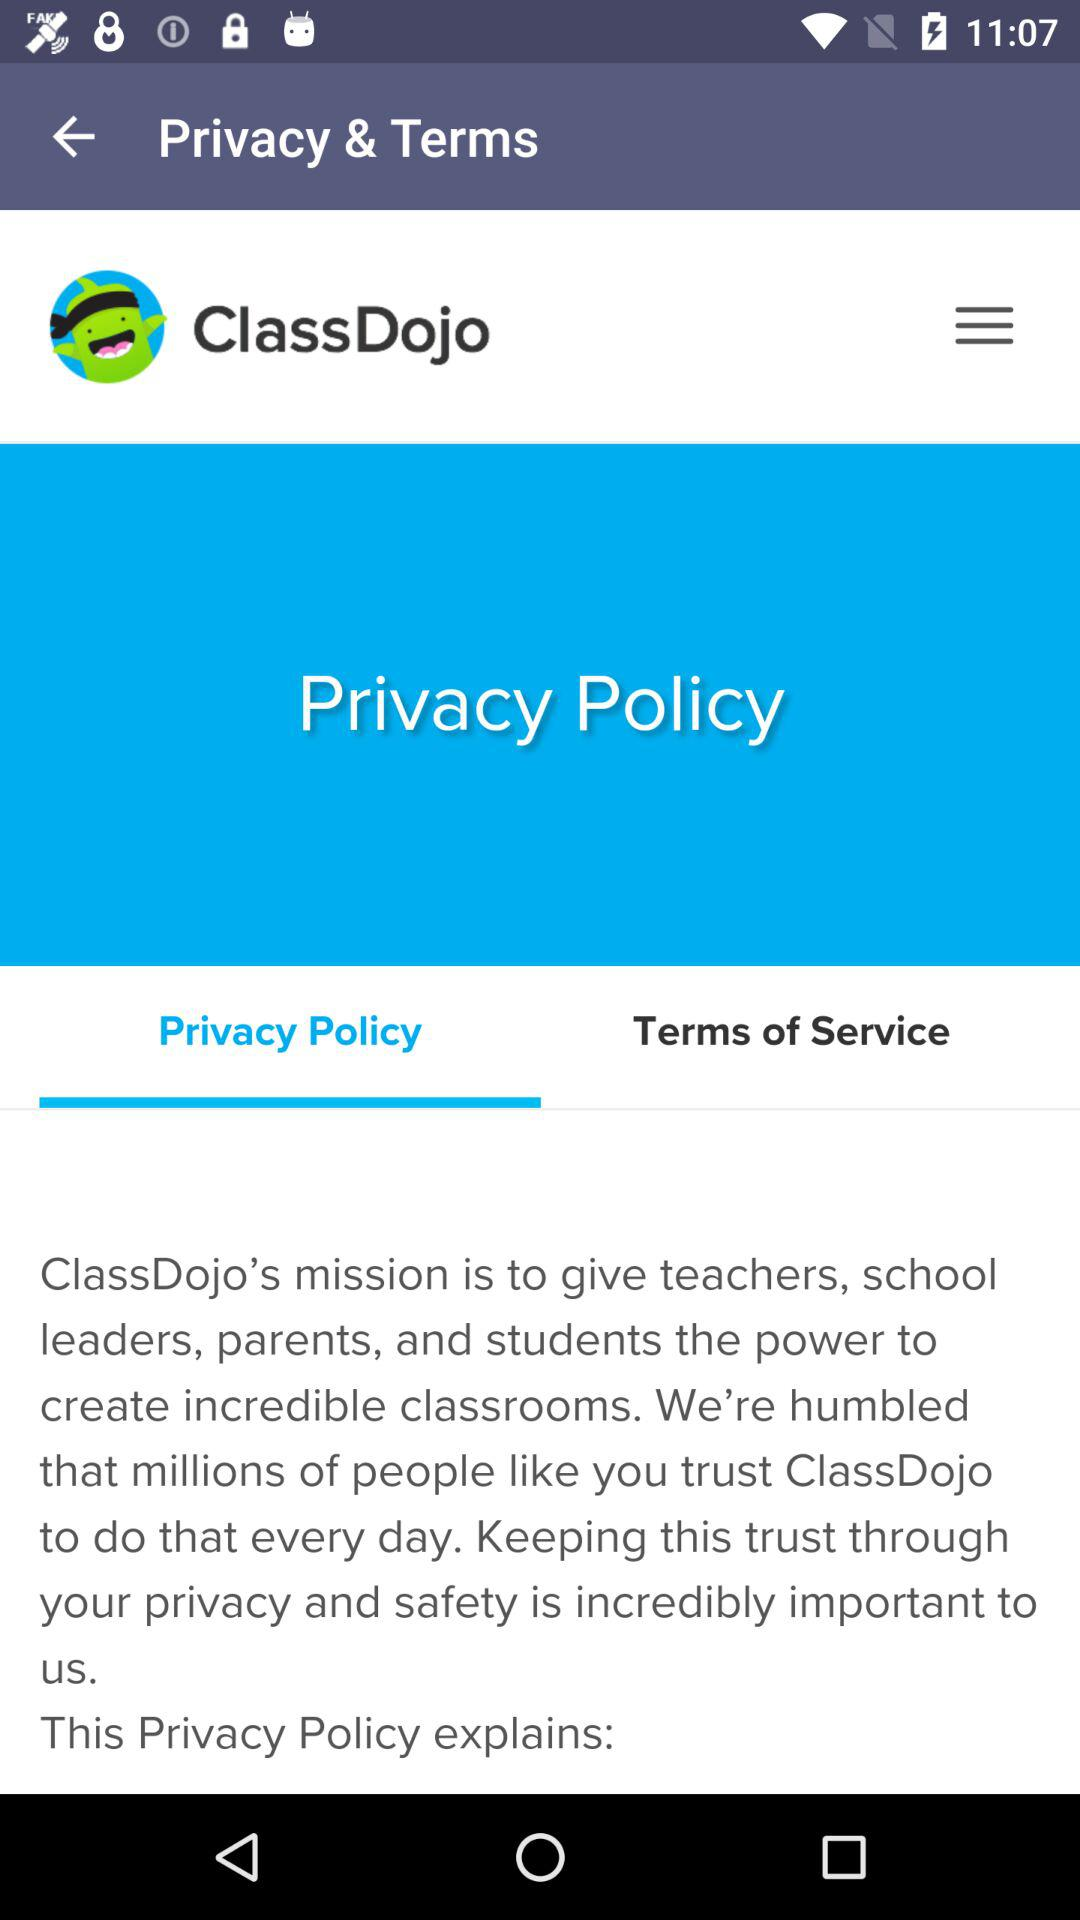What is the application name? The application name is "ClassDojo". 